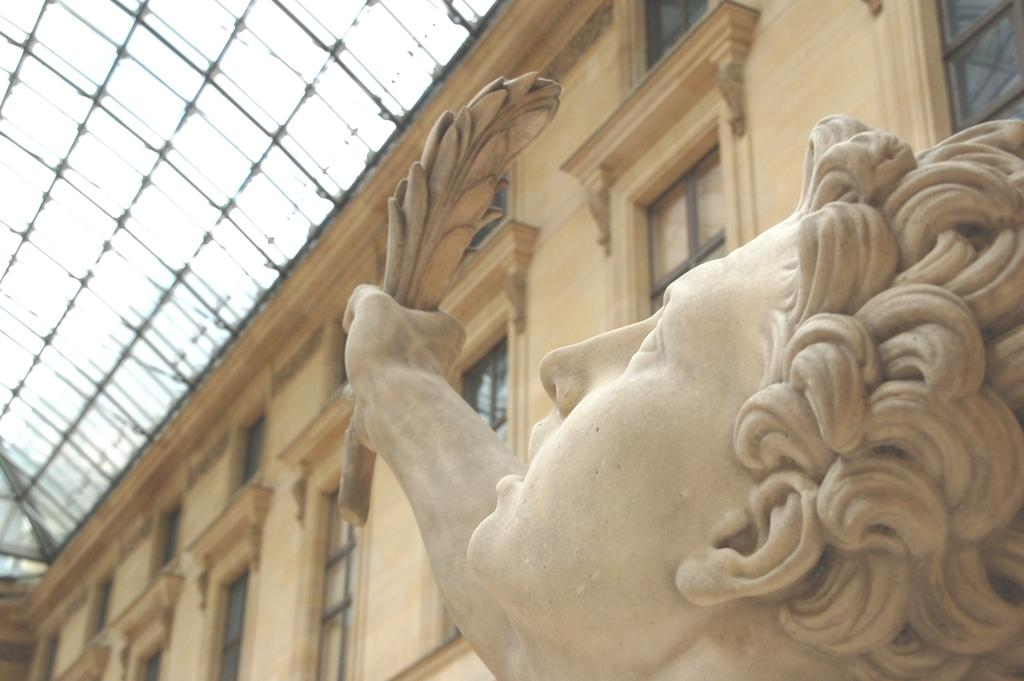What is the main subject in the front of the image? There is a statue in the front of the image. What can be seen in the background of the image? There is a building in the background of the image. What feature is present on top of the building? There is a shelter on top of the building. What type of lace can be seen on the statue in the image? There is no lace present on the statue in the image. How is the ink used in the image? There is no ink present in the image. 